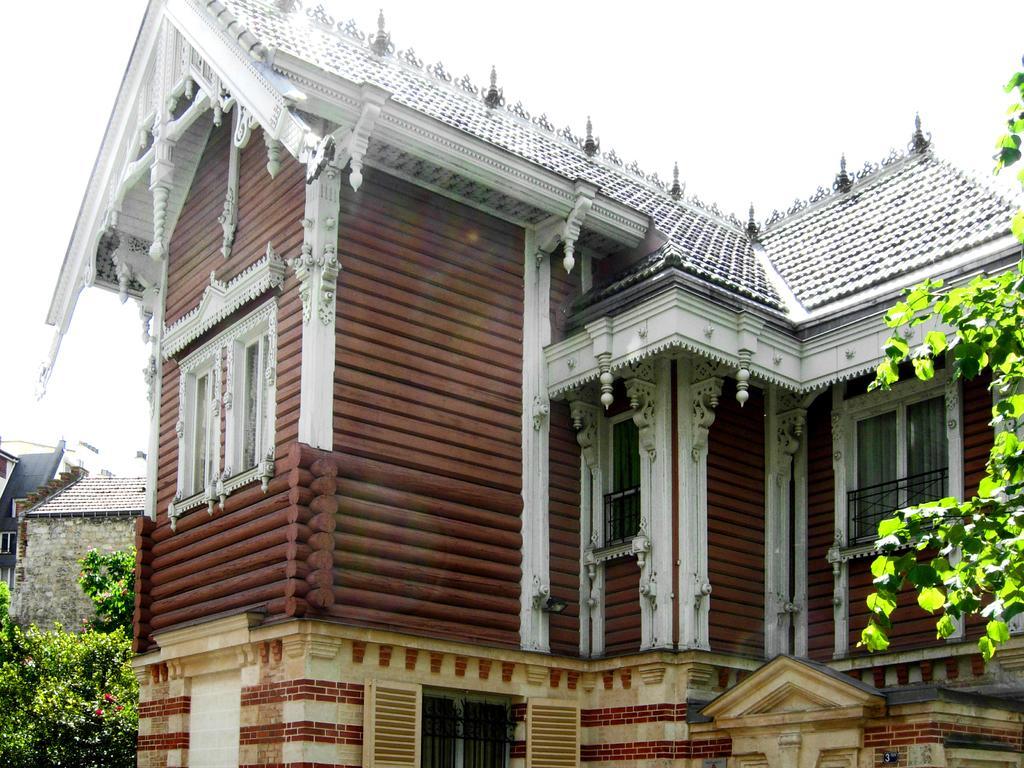Please provide a concise description of this image. In this image, there are a few houses. We can see some trees and the sky. We can also see some leaves on the right. 